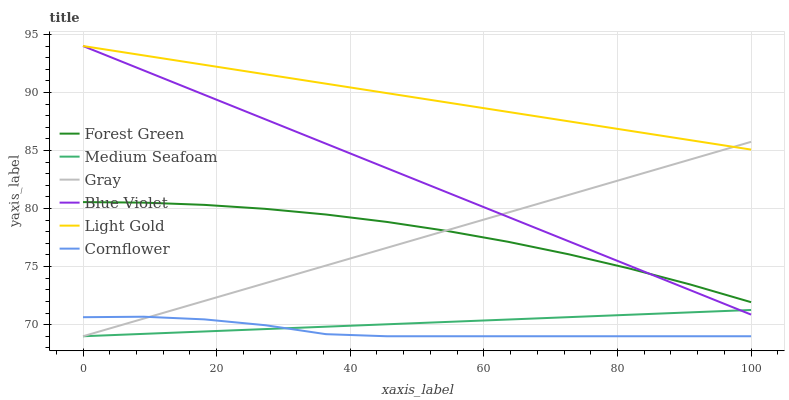Does Cornflower have the minimum area under the curve?
Answer yes or no. Yes. Does Light Gold have the maximum area under the curve?
Answer yes or no. Yes. Does Forest Green have the minimum area under the curve?
Answer yes or no. No. Does Forest Green have the maximum area under the curve?
Answer yes or no. No. Is Light Gold the smoothest?
Answer yes or no. Yes. Is Cornflower the roughest?
Answer yes or no. Yes. Is Forest Green the smoothest?
Answer yes or no. No. Is Forest Green the roughest?
Answer yes or no. No. Does Gray have the lowest value?
Answer yes or no. Yes. Does Forest Green have the lowest value?
Answer yes or no. No. Does Blue Violet have the highest value?
Answer yes or no. Yes. Does Forest Green have the highest value?
Answer yes or no. No. Is Medium Seafoam less than Forest Green?
Answer yes or no. Yes. Is Light Gold greater than Medium Seafoam?
Answer yes or no. Yes. Does Gray intersect Light Gold?
Answer yes or no. Yes. Is Gray less than Light Gold?
Answer yes or no. No. Is Gray greater than Light Gold?
Answer yes or no. No. Does Medium Seafoam intersect Forest Green?
Answer yes or no. No. 